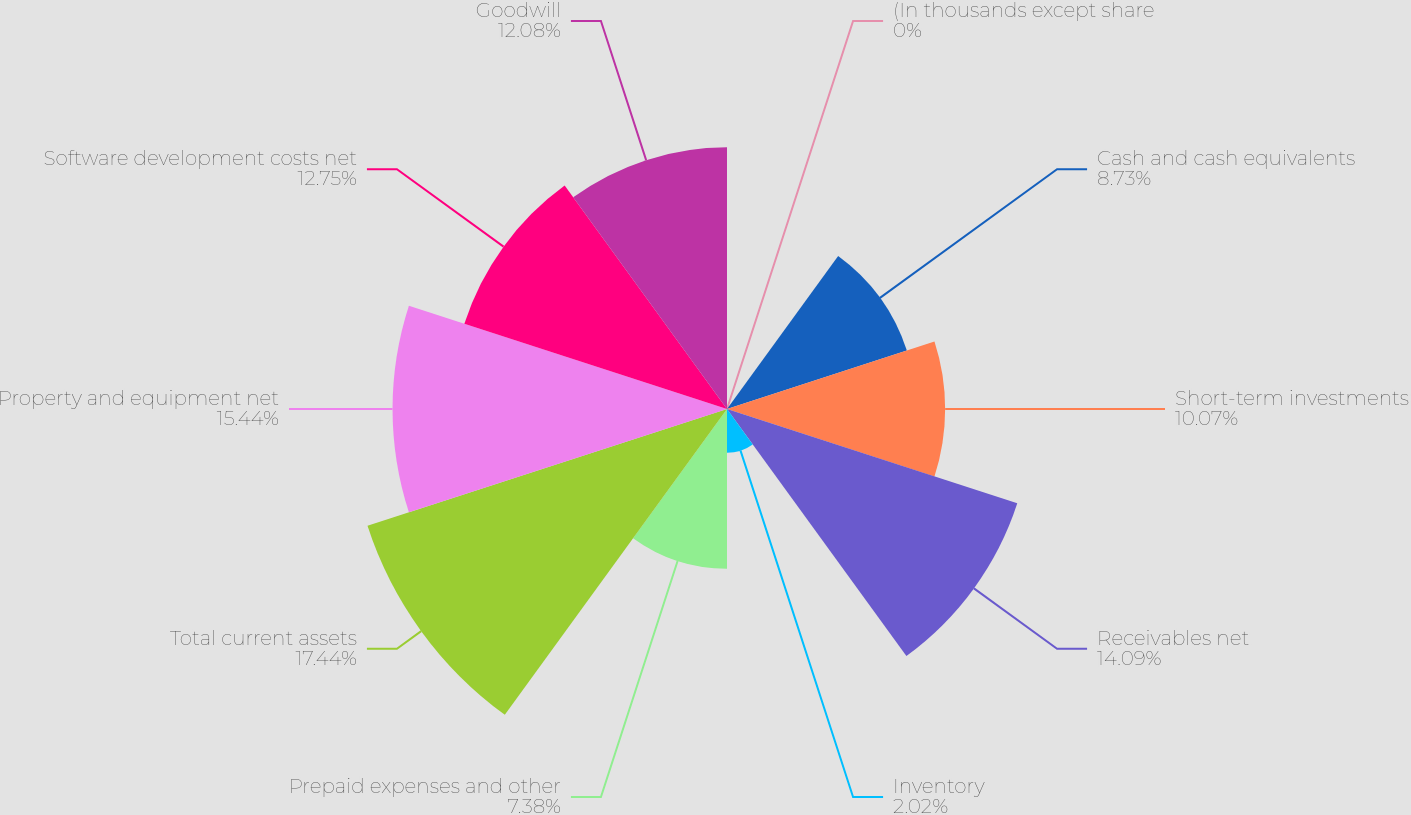<chart> <loc_0><loc_0><loc_500><loc_500><pie_chart><fcel>(In thousands except share<fcel>Cash and cash equivalents<fcel>Short-term investments<fcel>Receivables net<fcel>Inventory<fcel>Prepaid expenses and other<fcel>Total current assets<fcel>Property and equipment net<fcel>Software development costs net<fcel>Goodwill<nl><fcel>0.0%<fcel>8.73%<fcel>10.07%<fcel>14.09%<fcel>2.02%<fcel>7.38%<fcel>17.45%<fcel>15.44%<fcel>12.75%<fcel>12.08%<nl></chart> 